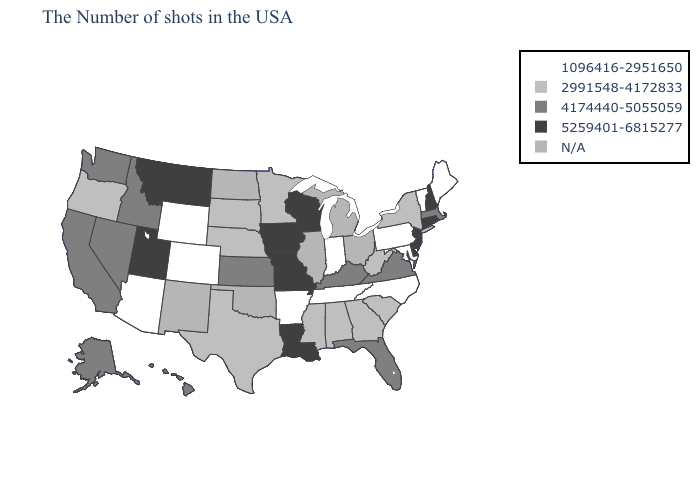Among the states that border Alabama , which have the lowest value?
Keep it brief. Tennessee. Which states have the highest value in the USA?
Concise answer only. Rhode Island, New Hampshire, Connecticut, New Jersey, Delaware, Wisconsin, Louisiana, Missouri, Iowa, Utah, Montana. What is the highest value in states that border Oregon?
Quick response, please. 4174440-5055059. Name the states that have a value in the range 2991548-4172833?
Be succinct. New York, South Carolina, West Virginia, Georgia, Alabama, Mississippi, Minnesota, Nebraska, Texas, South Dakota, Oregon. What is the highest value in states that border Rhode Island?
Keep it brief. 5259401-6815277. Which states have the lowest value in the USA?
Be succinct. Maine, Vermont, Maryland, Pennsylvania, North Carolina, Indiana, Tennessee, Arkansas, Wyoming, Colorado, Arizona. Name the states that have a value in the range 1096416-2951650?
Answer briefly. Maine, Vermont, Maryland, Pennsylvania, North Carolina, Indiana, Tennessee, Arkansas, Wyoming, Colorado, Arizona. Name the states that have a value in the range 5259401-6815277?
Keep it brief. Rhode Island, New Hampshire, Connecticut, New Jersey, Delaware, Wisconsin, Louisiana, Missouri, Iowa, Utah, Montana. Name the states that have a value in the range 4174440-5055059?
Quick response, please. Massachusetts, Virginia, Florida, Kentucky, Kansas, Idaho, Nevada, California, Washington, Alaska, Hawaii. Which states hav the highest value in the South?
Write a very short answer. Delaware, Louisiana. Among the states that border Georgia , which have the highest value?
Be succinct. Florida. What is the value of Nevada?
Give a very brief answer. 4174440-5055059. Name the states that have a value in the range 4174440-5055059?
Keep it brief. Massachusetts, Virginia, Florida, Kentucky, Kansas, Idaho, Nevada, California, Washington, Alaska, Hawaii. Does Arkansas have the highest value in the South?
Concise answer only. No. Name the states that have a value in the range N/A?
Answer briefly. Ohio, Michigan, Illinois, Oklahoma, North Dakota, New Mexico. 